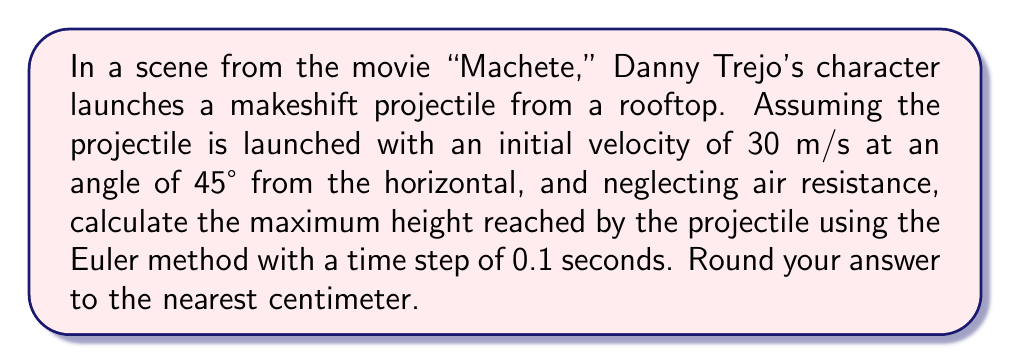Give your solution to this math problem. To solve this problem using the Euler method, we'll follow these steps:

1) First, let's define our variables:
   $v_x$ = x-component of velocity
   $v_y$ = y-component of velocity
   $x$ = horizontal position
   $y$ = vertical position
   $g$ = acceleration due to gravity (9.8 m/s²)
   $\Delta t$ = time step (0.1 s)

2) Initial conditions:
   $v_0 = 30$ m/s
   $\theta = 45°$
   $v_x = v_0 \cos(\theta) = 30 \cos(45°) = 21.21$ m/s
   $v_y = v_0 \sin(\theta) = 30 \sin(45°) = 21.21$ m/s
   $x_0 = 0$
   $y_0 = 0$

3) The Euler method uses the following equations:
   $$x_{n+1} = x_n + v_x \Delta t$$
   $$y_{n+1} = y_n + v_y \Delta t$$
   $$v_{y,n+1} = v_{y,n} - g \Delta t$$

4) We'll iterate until $v_y$ becomes negative, indicating the projectile has reached its peak:

   Step 0:
   $x_0 = 0$, $y_0 = 0$, $v_y = 21.21$

   Step 1:
   $x_1 = 0 + 21.21 * 0.1 = 2.121$
   $y_1 = 0 + 21.21 * 0.1 = 2.121$
   $v_y = 21.21 - 9.8 * 0.1 = 20.23$

   Step 2:
   $x_2 = 2.121 + 21.21 * 0.1 = 4.242$
   $y_2 = 2.121 + 20.23 * 0.1 = 4.144$
   $v_y = 20.23 - 9.8 * 0.1 = 19.25$

   ...

   Step 21:
   $x_{21} = 44.541$
   $y_{21} = 22.558$
   $v_y = 0.49 - 9.8 * 0.1 = -0.49$

5) The projectile reaches its maximum height when $v_y$ becomes negative, which occurs at step 21. Therefore, the maximum height is 22.558 meters.

6) Rounding to the nearest centimeter gives us 22.56 meters.
Answer: 22.56 meters 